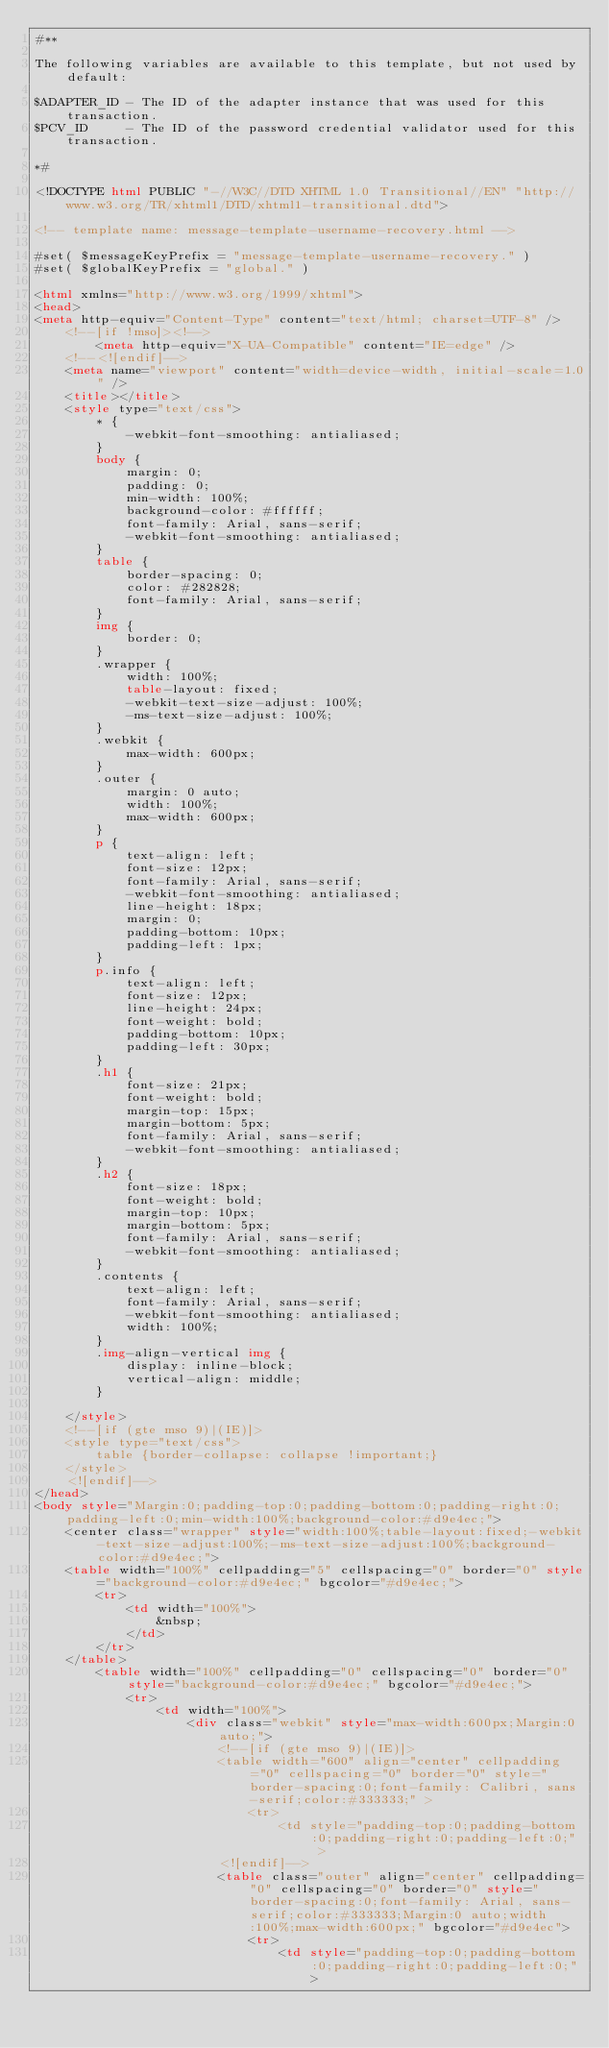Convert code to text. <code><loc_0><loc_0><loc_500><loc_500><_HTML_>#**

The following variables are available to this template, but not used by default:

$ADAPTER_ID - The ID of the adapter instance that was used for this transaction.
$PCV_ID     - The ID of the password credential validator used for this transaction.

*#

<!DOCTYPE html PUBLIC "-//W3C//DTD XHTML 1.0 Transitional//EN" "http://www.w3.org/TR/xhtml1/DTD/xhtml1-transitional.dtd">

<!-- template name: message-template-username-recovery.html -->

#set( $messageKeyPrefix = "message-template-username-recovery." )
#set( $globalKeyPrefix = "global." )

<html xmlns="http://www.w3.org/1999/xhtml">
<head>
<meta http-equiv="Content-Type" content="text/html; charset=UTF-8" />
	<!--[if !mso]><!-->
		<meta http-equiv="X-UA-Compatible" content="IE=edge" />
	<!--<![endif]-->
	<meta name="viewport" content="width=device-width, initial-scale=1.0" />
	<title></title>
	<style type="text/css">
		* {
			-webkit-font-smoothing: antialiased;
		}
		body {
			margin: 0;
			padding: 0;
			min-width: 100%;
			background-color: #ffffff;
			font-family: Arial, sans-serif;
			-webkit-font-smoothing: antialiased;
		}
		table {
			border-spacing: 0;
			color: #282828;
			font-family: Arial, sans-serif;
		}
		img {
			border: 0;
		}
		.wrapper {
			width: 100%;
			table-layout: fixed;
			-webkit-text-size-adjust: 100%;
			-ms-text-size-adjust: 100%;
		}
		.webkit {
			max-width: 600px;
		}
		.outer {
			margin: 0 auto;
			width: 100%;
			max-width: 600px;
		}
		p {
			text-align: left;
			font-size: 12px;
			font-family: Arial, sans-serif;
			-webkit-font-smoothing: antialiased;
			line-height: 18px;
			margin: 0;
			padding-bottom: 10px;
			padding-left: 1px;
		}
		p.info {
			text-align: left;
			font-size: 12px;
			line-height: 24px;
			font-weight: bold;
			padding-bottom: 10px;
			padding-left: 30px;
		}
		.h1 {
			font-size: 21px;
			font-weight: bold;
			margin-top: 15px;
			margin-bottom: 5px;
			font-family: Arial, sans-serif;
			-webkit-font-smoothing: antialiased;
		}
		.h2 {
			font-size: 18px;
			font-weight: bold;
			margin-top: 10px;
			margin-bottom: 5px;
			font-family: Arial, sans-serif;
			-webkit-font-smoothing: antialiased;
		}
		.contents {
			text-align: left;
			font-family: Arial, sans-serif;
			-webkit-font-smoothing: antialiased;
			width: 100%;
		}
		.img-align-vertical img {
			display: inline-block;
			vertical-align: middle;
		}

	</style>
	<!--[if (gte mso 9)|(IE)]>
	<style type="text/css">
		table {border-collapse: collapse !important;}
	</style>
	<![endif]-->
</head>
<body style="Margin:0;padding-top:0;padding-bottom:0;padding-right:0;padding-left:0;min-width:100%;background-color:#d9e4ec;">
	<center class="wrapper" style="width:100%;table-layout:fixed;-webkit-text-size-adjust:100%;-ms-text-size-adjust:100%;background-color:#d9e4ec;">
    <table width="100%" cellpadding="5" cellspacing="0" border="0" style="background-color:#d9e4ec;" bgcolor="#d9e4ec;">
    	<tr>
        	<td width="100%">
                &nbsp;
            </td>
        </tr>
    </table>
		<table width="100%" cellpadding="0" cellspacing="0" border="0" style="background-color:#d9e4ec;" bgcolor="#d9e4ec;">
			<tr>
				<td width="100%">
					<div class="webkit" style="max-width:600px;Margin:0 auto;">
						<!--[if (gte mso 9)|(IE)]>
						<table width="600" align="center" cellpadding="0" cellspacing="0" border="0" style="border-spacing:0;font-family: Calibri, sans-serif;color:#333333;" >
							<tr>
								<td style="padding-top:0;padding-bottom:0;padding-right:0;padding-left:0;" >
						<![endif]-->
						<table class="outer" align="center" cellpadding="0" cellspacing="0" border="0" style="border-spacing:0;font-family: Arial, sans-serif;color:#333333;Margin:0 auto;width:100%;max-width:600px;" bgcolor="#d9e4ec">
							<tr>
								<td style="padding-top:0;padding-bottom:0;padding-right:0;padding-left:0;"></code> 